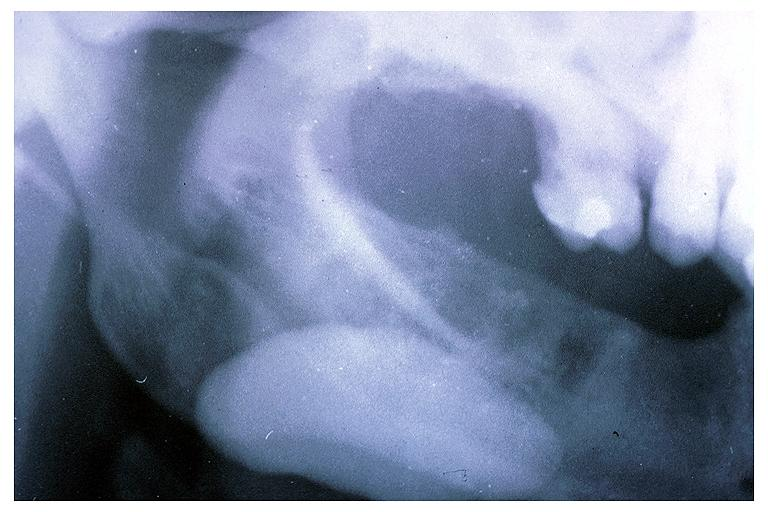does one show sialolith?
Answer the question using a single word or phrase. No 